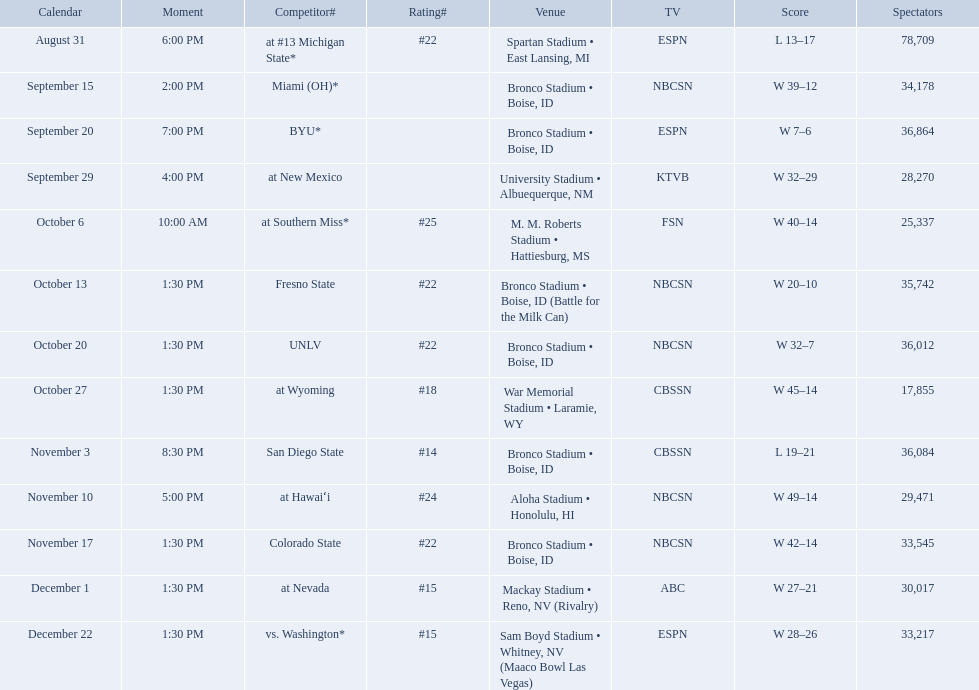Who were all of the opponents? At #13 michigan state*, miami (oh)*, byu*, at new mexico, at southern miss*, fresno state, unlv, at wyoming, san diego state, at hawaiʻi, colorado state, at nevada, vs. washington*. Who did they face on november 3rd? San Diego State. What rank were they on november 3rd? #14. What are the opponent teams of the 2012 boise state broncos football team? At #13 michigan state*, miami (oh)*, byu*, at new mexico, at southern miss*, fresno state, unlv, at wyoming, san diego state, at hawaiʻi, colorado state, at nevada, vs. washington*. How has the highest rank of these opponents? San Diego State. What are the opponents to the  2012 boise state broncos football team? At #13 michigan state*, miami (oh)*, byu*, at new mexico, at southern miss*, fresno state, unlv, at wyoming, san diego state, at hawaiʻi, colorado state, at nevada, vs. washington*. Which is the highest ranked of the teams? San Diego State. 